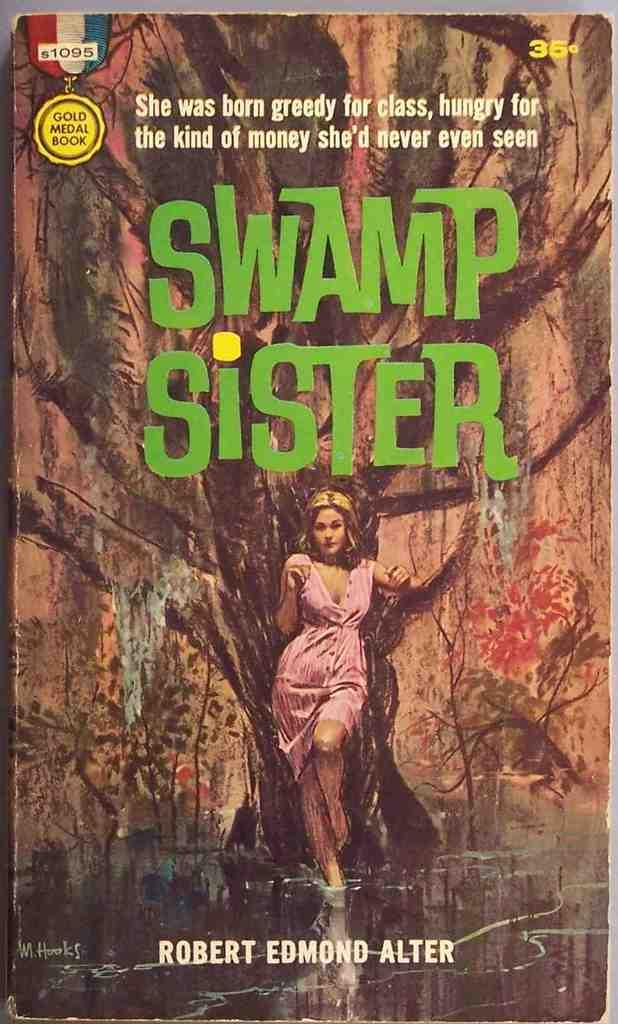<image>
Create a compact narrative representing the image presented. A book called "Swamp Sister" that has a girl in front of a tree on it 